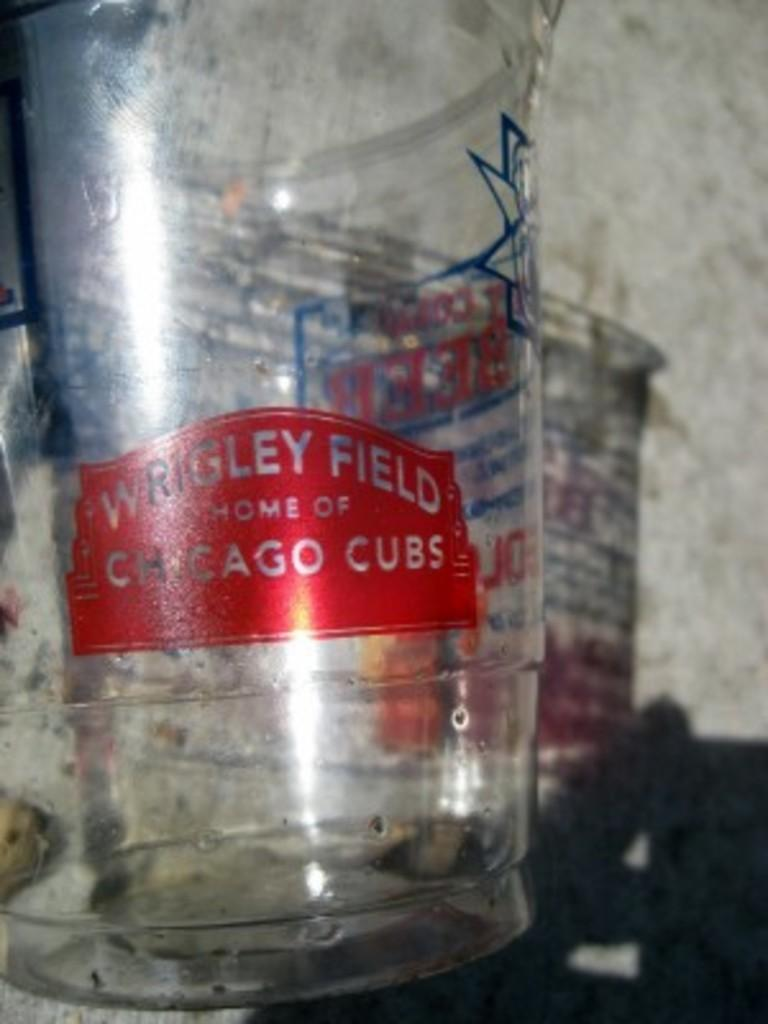<image>
Provide a brief description of the given image. A plastic cup from Wrigley Field laying on the pavement. 